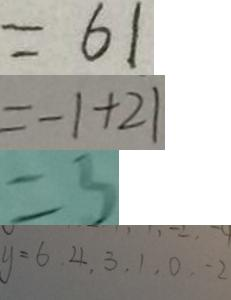Convert formula to latex. <formula><loc_0><loc_0><loc_500><loc_500>= 6 1 
 = - 1 + 2 1 
 = 3 
 y = 6 , 4 , 3 , 1 , 0 , - 2</formula> 